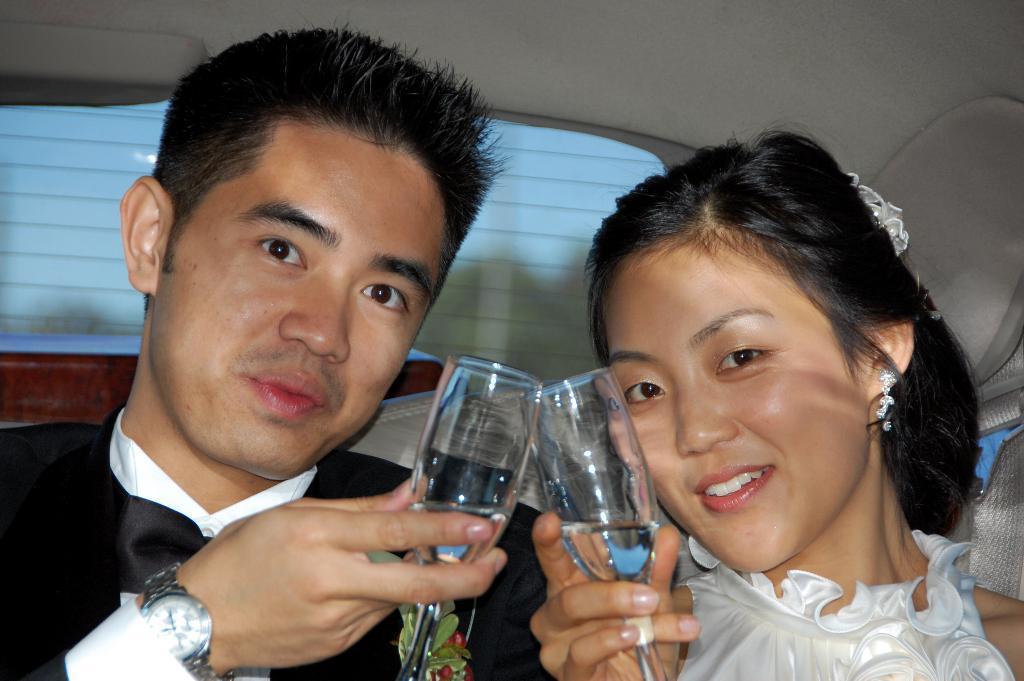How would you summarize this image in a sentence or two? In this image we can see a couple who are sitting inside a car and they are holding a glass of wine in their hand. 